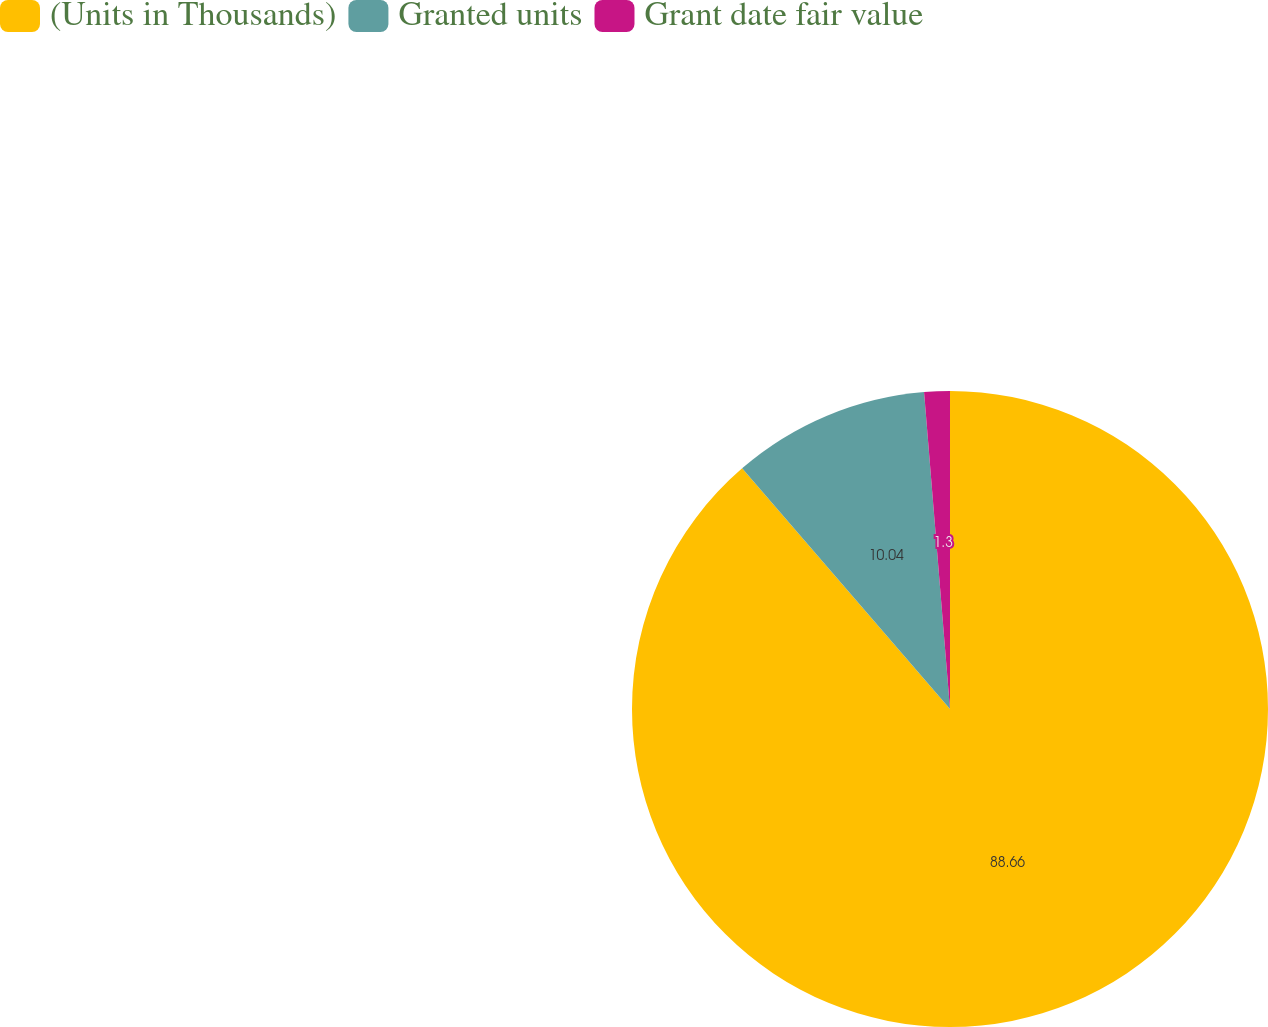Convert chart to OTSL. <chart><loc_0><loc_0><loc_500><loc_500><pie_chart><fcel>(Units in Thousands)<fcel>Granted units<fcel>Grant date fair value<nl><fcel>88.66%<fcel>10.04%<fcel>1.3%<nl></chart> 